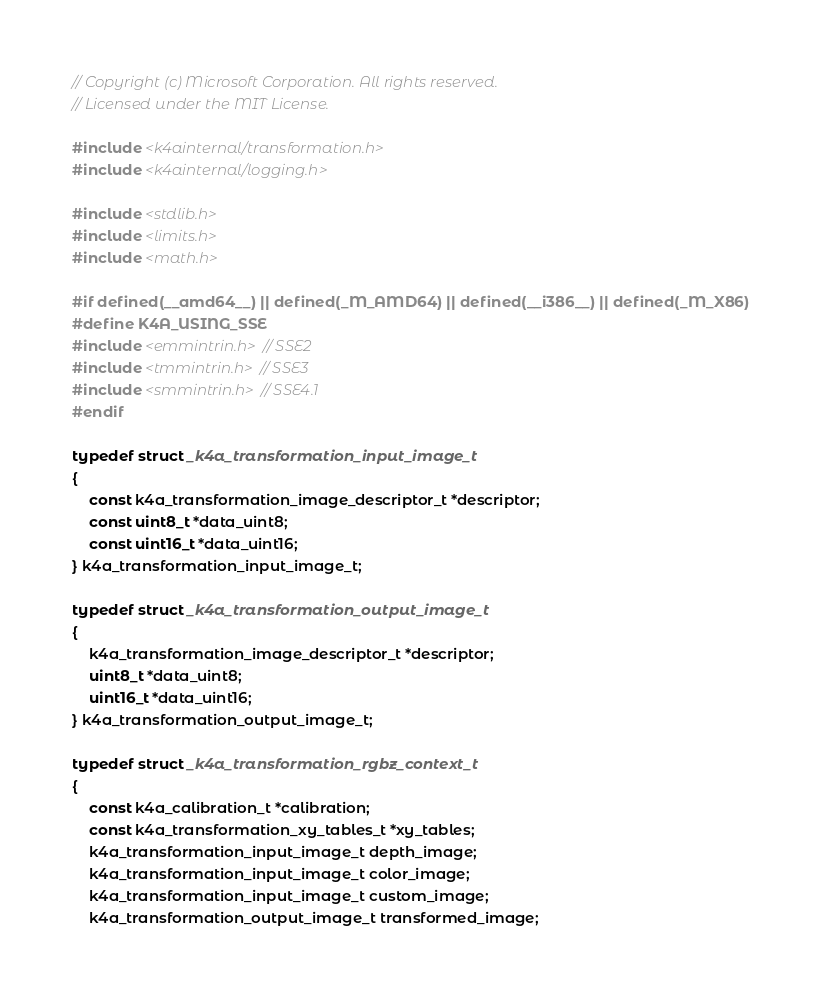Convert code to text. <code><loc_0><loc_0><loc_500><loc_500><_C_>// Copyright (c) Microsoft Corporation. All rights reserved.
// Licensed under the MIT License.

#include <k4ainternal/transformation.h>
#include <k4ainternal/logging.h>

#include <stdlib.h>
#include <limits.h>
#include <math.h>

#if defined(__amd64__) || defined(_M_AMD64) || defined(__i386__) || defined(_M_X86)
#define K4A_USING_SSE
#include <emmintrin.h> // SSE2
#include <tmmintrin.h> // SSE3
#include <smmintrin.h> // SSE4.1
#endif

typedef struct _k4a_transformation_input_image_t
{
    const k4a_transformation_image_descriptor_t *descriptor;
    const uint8_t *data_uint8;
    const uint16_t *data_uint16;
} k4a_transformation_input_image_t;

typedef struct _k4a_transformation_output_image_t
{
    k4a_transformation_image_descriptor_t *descriptor;
    uint8_t *data_uint8;
    uint16_t *data_uint16;
} k4a_transformation_output_image_t;

typedef struct _k4a_transformation_rgbz_context_t
{
    const k4a_calibration_t *calibration;
    const k4a_transformation_xy_tables_t *xy_tables;
    k4a_transformation_input_image_t depth_image;
    k4a_transformation_input_image_t color_image;
    k4a_transformation_input_image_t custom_image;
    k4a_transformation_output_image_t transformed_image;</code> 